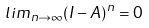Convert formula to latex. <formula><loc_0><loc_0><loc_500><loc_500>l i m _ { n \rightarrow \infty } ( I - A ) ^ { n } = 0</formula> 